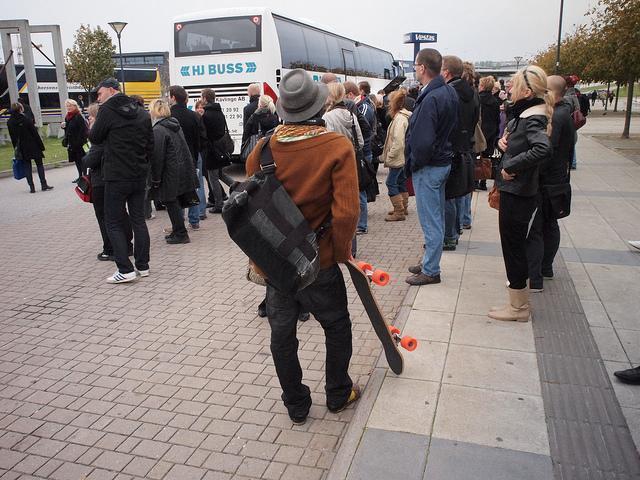How many skateboards are in the picture?
Give a very brief answer. 1. How many people can be seen?
Give a very brief answer. 8. 